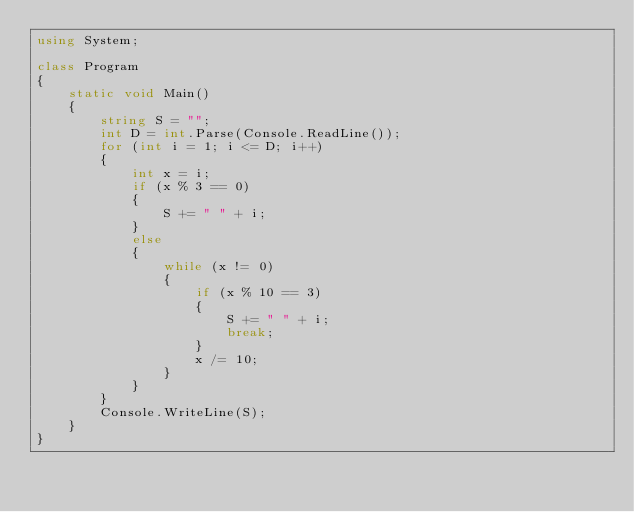<code> <loc_0><loc_0><loc_500><loc_500><_C#_>using System;

class Program
{
	static void Main()
	{
		string S = "";
		int D = int.Parse(Console.ReadLine());
		for (int i = 1; i <= D; i++)
		{
			int x = i;
			if (x % 3 == 0)
			{
				S += " " + i;
			}
			else
			{
				while (x != 0)
				{
					if (x % 10 == 3)
					{
						S += " " + i;
						break;
					}
					x /= 10;
				}
			}
		}
		Console.WriteLine(S);
	}
}</code> 